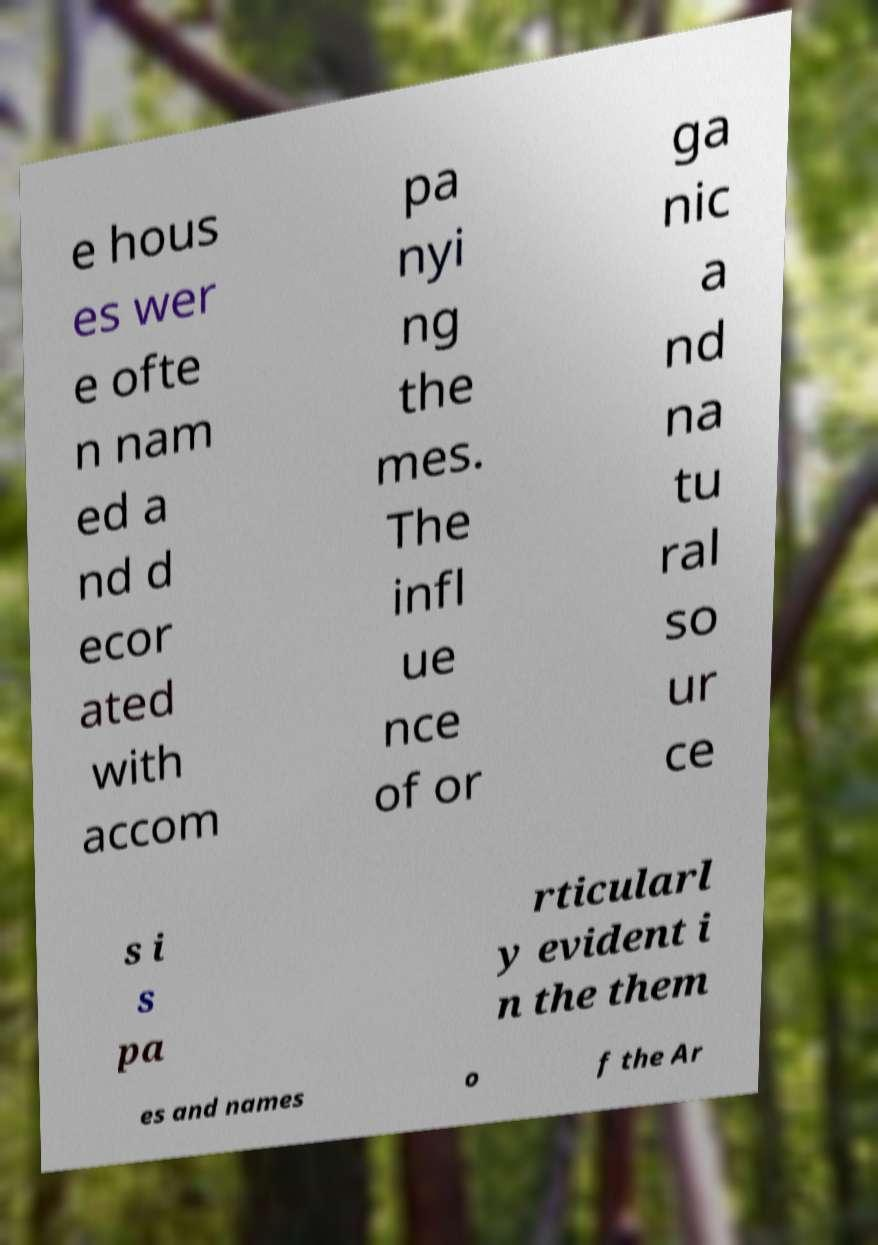I need the written content from this picture converted into text. Can you do that? e hous es wer e ofte n nam ed a nd d ecor ated with accom pa nyi ng the mes. The infl ue nce of or ga nic a nd na tu ral so ur ce s i s pa rticularl y evident i n the them es and names o f the Ar 